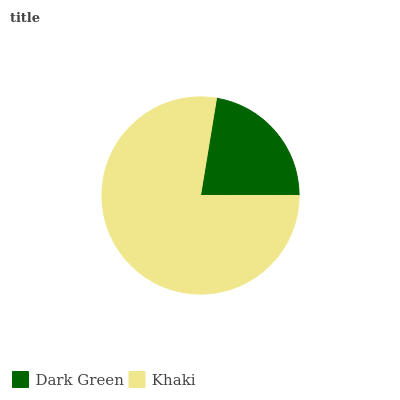Is Dark Green the minimum?
Answer yes or no. Yes. Is Khaki the maximum?
Answer yes or no. Yes. Is Khaki the minimum?
Answer yes or no. No. Is Khaki greater than Dark Green?
Answer yes or no. Yes. Is Dark Green less than Khaki?
Answer yes or no. Yes. Is Dark Green greater than Khaki?
Answer yes or no. No. Is Khaki less than Dark Green?
Answer yes or no. No. Is Khaki the high median?
Answer yes or no. Yes. Is Dark Green the low median?
Answer yes or no. Yes. Is Dark Green the high median?
Answer yes or no. No. Is Khaki the low median?
Answer yes or no. No. 